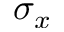Convert formula to latex. <formula><loc_0><loc_0><loc_500><loc_500>\sigma _ { x }</formula> 